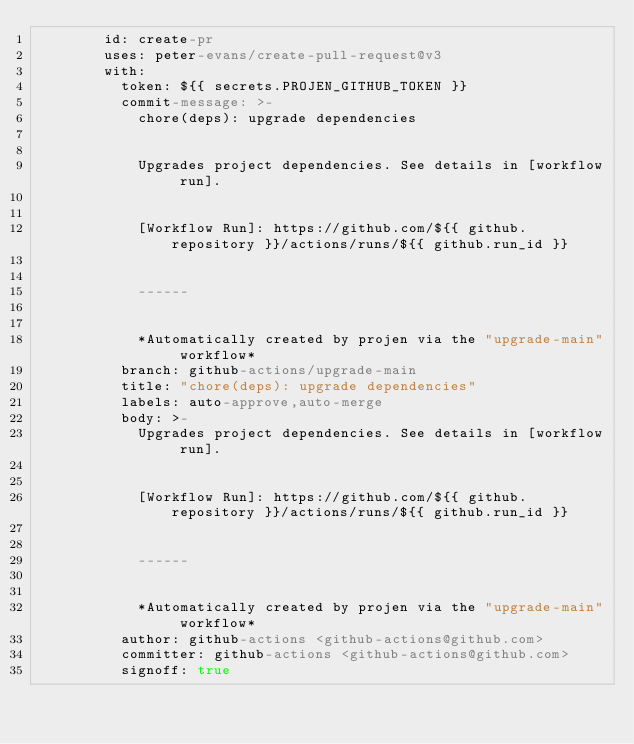<code> <loc_0><loc_0><loc_500><loc_500><_YAML_>        id: create-pr
        uses: peter-evans/create-pull-request@v3
        with:
          token: ${{ secrets.PROJEN_GITHUB_TOKEN }}
          commit-message: >-
            chore(deps): upgrade dependencies


            Upgrades project dependencies. See details in [workflow run].


            [Workflow Run]: https://github.com/${{ github.repository }}/actions/runs/${{ github.run_id }}


            ------


            *Automatically created by projen via the "upgrade-main" workflow*
          branch: github-actions/upgrade-main
          title: "chore(deps): upgrade dependencies"
          labels: auto-approve,auto-merge
          body: >-
            Upgrades project dependencies. See details in [workflow run].


            [Workflow Run]: https://github.com/${{ github.repository }}/actions/runs/${{ github.run_id }}


            ------


            *Automatically created by projen via the "upgrade-main" workflow*
          author: github-actions <github-actions@github.com>
          committer: github-actions <github-actions@github.com>
          signoff: true
</code> 